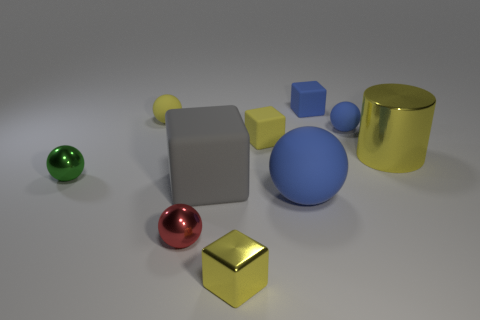Subtract all yellow balls. How many balls are left? 4 Subtract all red cylinders. How many blue spheres are left? 2 Subtract all blue blocks. How many blocks are left? 3 Subtract 2 cubes. How many cubes are left? 2 Subtract all cubes. How many objects are left? 6 Subtract all cyan matte objects. Subtract all small yellow matte balls. How many objects are left? 9 Add 1 small metal spheres. How many small metal spheres are left? 3 Add 6 blue rubber cubes. How many blue rubber cubes exist? 7 Subtract 0 purple balls. How many objects are left? 10 Subtract all cyan blocks. Subtract all green cylinders. How many blocks are left? 4 